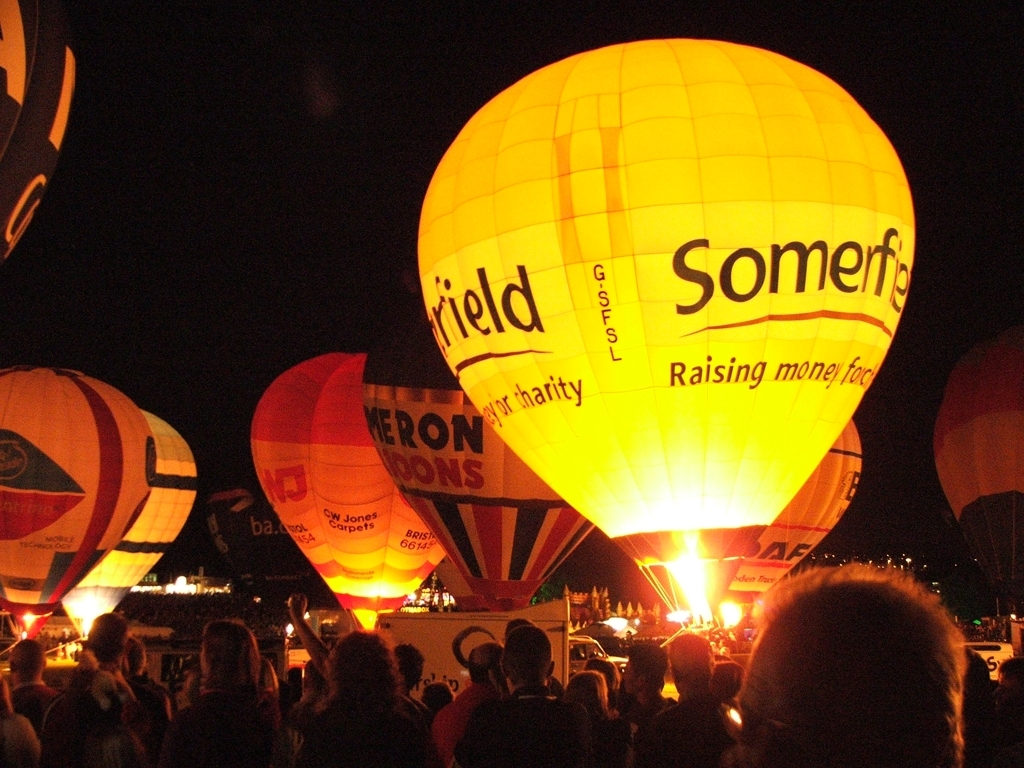Can this image display text information on the hot air balloon? Indeed, the image clearly shows illuminated hot air balloons at night, each with text on their surface. This text is often used by companies or organizations for advertising or spreading awareness about a cause, as evidenced by phrases like 'Raising money for charity,' suggesting these balloons are part of a charitable event. 